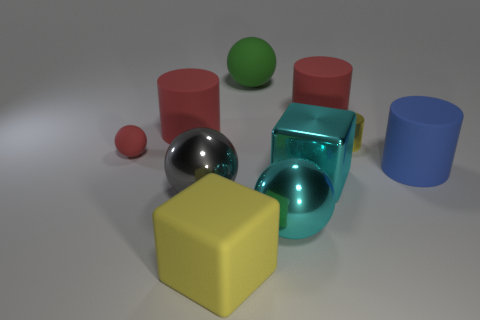Subtract 1 cylinders. How many cylinders are left? 3 Subtract all cyan metallic balls. How many balls are left? 3 Subtract all blue balls. Subtract all gray blocks. How many balls are left? 4 Subtract all balls. How many objects are left? 6 Subtract all large yellow metal blocks. Subtract all cyan balls. How many objects are left? 9 Add 6 small yellow cylinders. How many small yellow cylinders are left? 7 Add 3 blue things. How many blue things exist? 4 Subtract 0 green cubes. How many objects are left? 10 